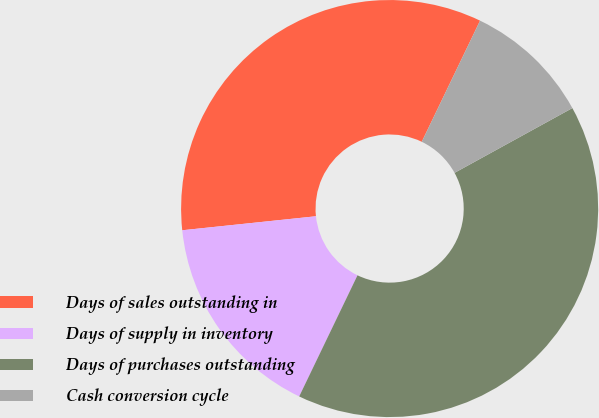Convert chart. <chart><loc_0><loc_0><loc_500><loc_500><pie_chart><fcel>Days of sales outstanding in<fcel>Days of supply in inventory<fcel>Days of purchases outstanding<fcel>Cash conversion cycle<nl><fcel>33.8%<fcel>16.2%<fcel>40.14%<fcel>9.86%<nl></chart> 